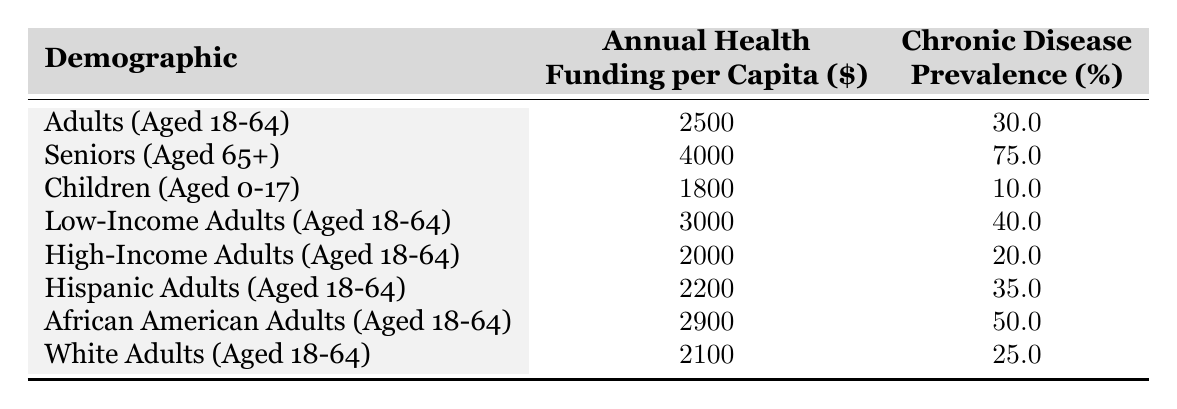What is the annual health funding per capita for seniors aged 65 and older? The table lists the annual health funding per capita for seniors (aged 65+) as $4000.
Answer: 4000 Which demographic has the highest chronic disease prevalence percentage? The seniors (aged 65+) have the highest chronic disease prevalence percentage, which is 75%.
Answer: 75 How much higher is the health funding per capita for seniors compared to children? The annual health funding per capita for seniors is $4000 and for children it is $1800. The difference is $4000 - $1800 = $2200.
Answer: 2200 Is the chronic disease prevalence for high-income adults higher than for low-income adults? High-income adults (20%) have a lower chronic disease prevalence than low-income adults (40%). Therefore, the statement is false.
Answer: No What is the average chronic disease prevalence percentage across all demographics listed? To find the average, add all prevalence percentages: (30 + 75 + 10 + 40 + 20 + 35 + 50 + 25) = 285. There are 8 demographics, so divide by 8: 285/8 = 35.625.
Answer: 35.625 Do African American adults have a lower health funding per capita than Hispanic adults? African American adults have health funding of $2900, while Hispanic adults have $2200. Since $2900 is higher than $2200, the statement is false.
Answer: No How does the health funding per capita for low-income adults compare to that of high-income adults? The health funding per capita for low-income adults is $3000, while for high-income adults it is $2000. The difference is $3000 - $2000 = $1000, so low-income adults have more funding.
Answer: $1000 Which demographic group has the lowest chronic disease prevalence? The demographic with the lowest chronic disease prevalence is children (aged 0-17) at 10%.
Answer: 10 What is the total annual health funding for all demographics combined? The total is calculated as the sum of all funding amounts: 2500 + 4000 + 1800 + 3000 + 2000 + 2200 + 2900 + 2100 = 22600.
Answer: 22600 